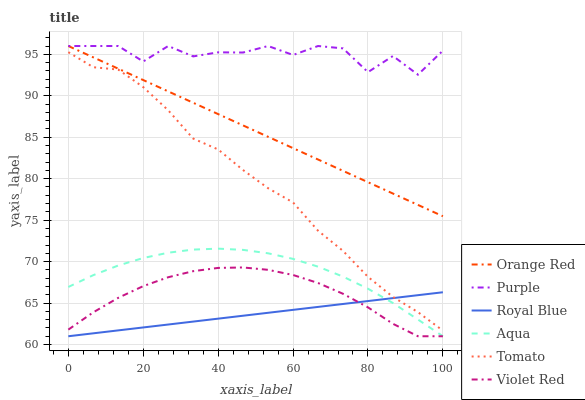Does Royal Blue have the minimum area under the curve?
Answer yes or no. Yes. Does Purple have the maximum area under the curve?
Answer yes or no. Yes. Does Violet Red have the minimum area under the curve?
Answer yes or no. No. Does Violet Red have the maximum area under the curve?
Answer yes or no. No. Is Royal Blue the smoothest?
Answer yes or no. Yes. Is Purple the roughest?
Answer yes or no. Yes. Is Violet Red the smoothest?
Answer yes or no. No. Is Violet Red the roughest?
Answer yes or no. No. Does Purple have the lowest value?
Answer yes or no. No. Does Violet Red have the highest value?
Answer yes or no. No. Is Aqua less than Tomato?
Answer yes or no. Yes. Is Purple greater than Royal Blue?
Answer yes or no. Yes. Does Aqua intersect Tomato?
Answer yes or no. No. 